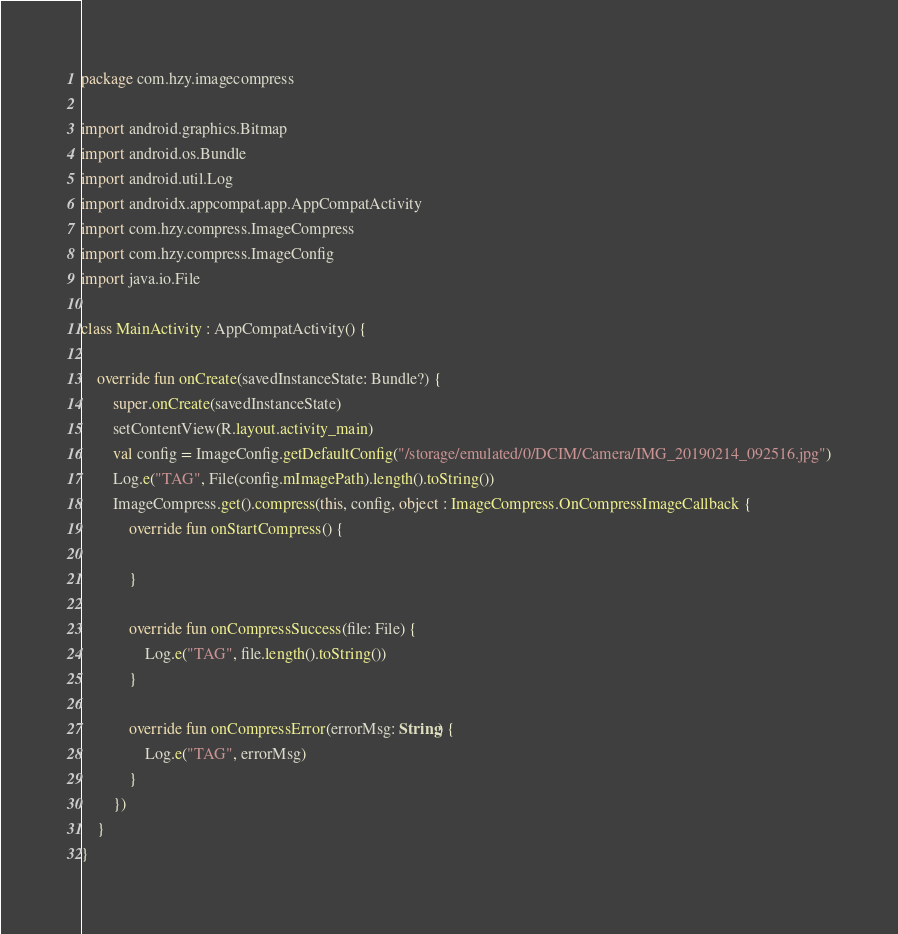<code> <loc_0><loc_0><loc_500><loc_500><_Kotlin_>package com.hzy.imagecompress

import android.graphics.Bitmap
import android.os.Bundle
import android.util.Log
import androidx.appcompat.app.AppCompatActivity
import com.hzy.compress.ImageCompress
import com.hzy.compress.ImageConfig
import java.io.File

class MainActivity : AppCompatActivity() {

    override fun onCreate(savedInstanceState: Bundle?) {
        super.onCreate(savedInstanceState)
        setContentView(R.layout.activity_main)
        val config = ImageConfig.getDefaultConfig("/storage/emulated/0/DCIM/Camera/IMG_20190214_092516.jpg")
        Log.e("TAG", File(config.mImagePath).length().toString())
        ImageCompress.get().compress(this, config, object : ImageCompress.OnCompressImageCallback {
            override fun onStartCompress() {

            }

            override fun onCompressSuccess(file: File) {
                Log.e("TAG", file.length().toString())
            }

            override fun onCompressError(errorMsg: String) {
                Log.e("TAG", errorMsg)
            }
        })
    }
}
</code> 